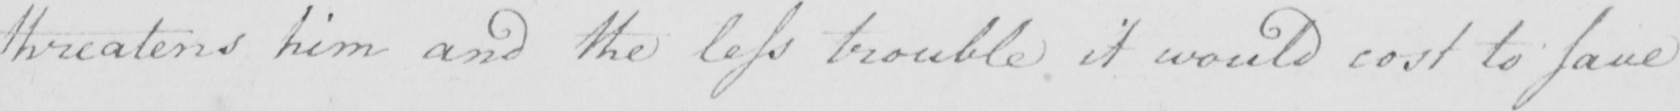Transcribe the text shown in this historical manuscript line. threatens him and the less trouble it would cost to save 